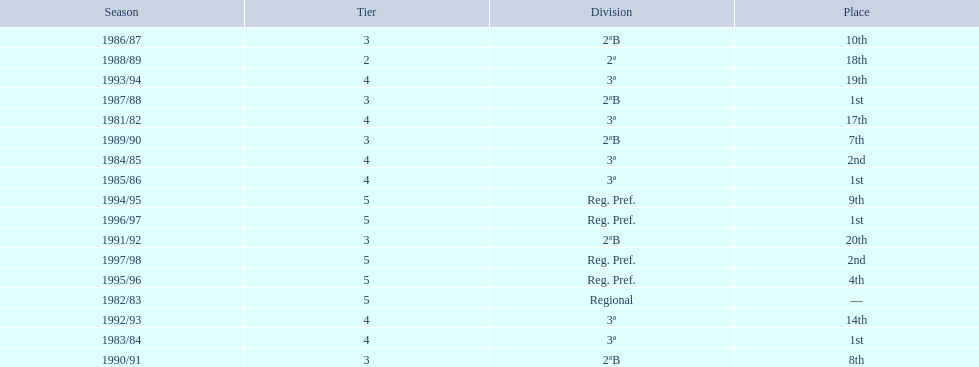When is the last year that the team has been division 2? 1991/92. 